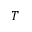<formula> <loc_0><loc_0><loc_500><loc_500>T</formula> 